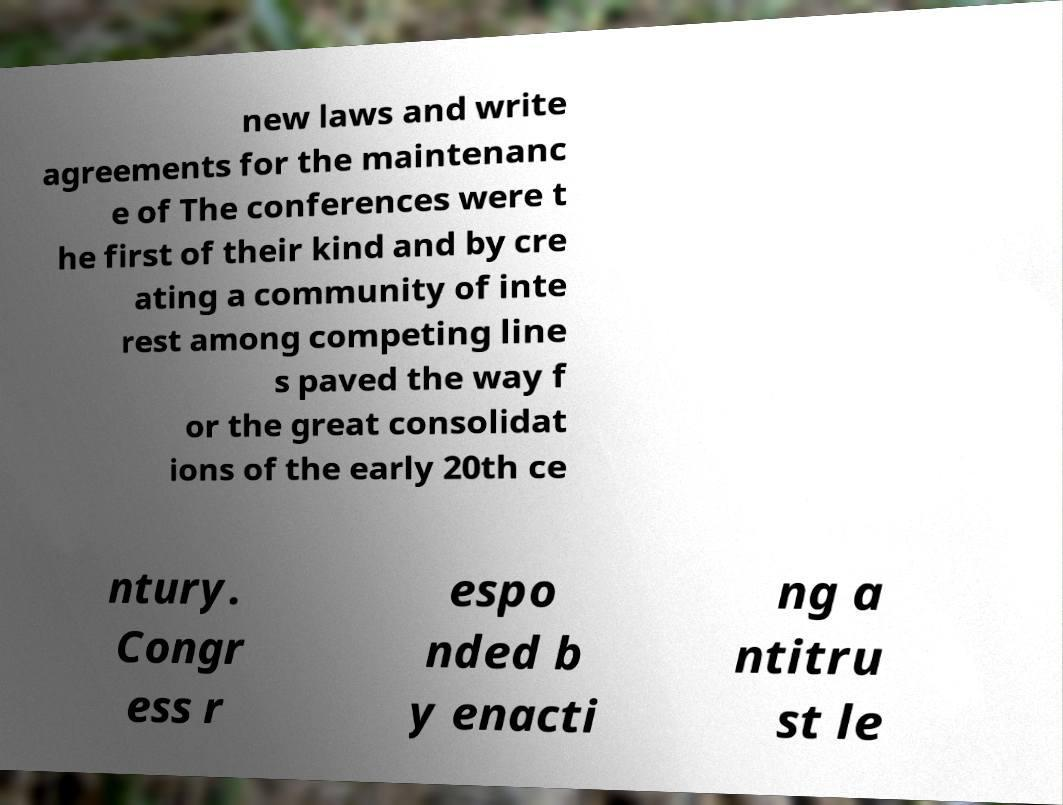Please read and relay the text visible in this image. What does it say? new laws and write agreements for the maintenanc e of The conferences were t he first of their kind and by cre ating a community of inte rest among competing line s paved the way f or the great consolidat ions of the early 20th ce ntury. Congr ess r espo nded b y enacti ng a ntitru st le 